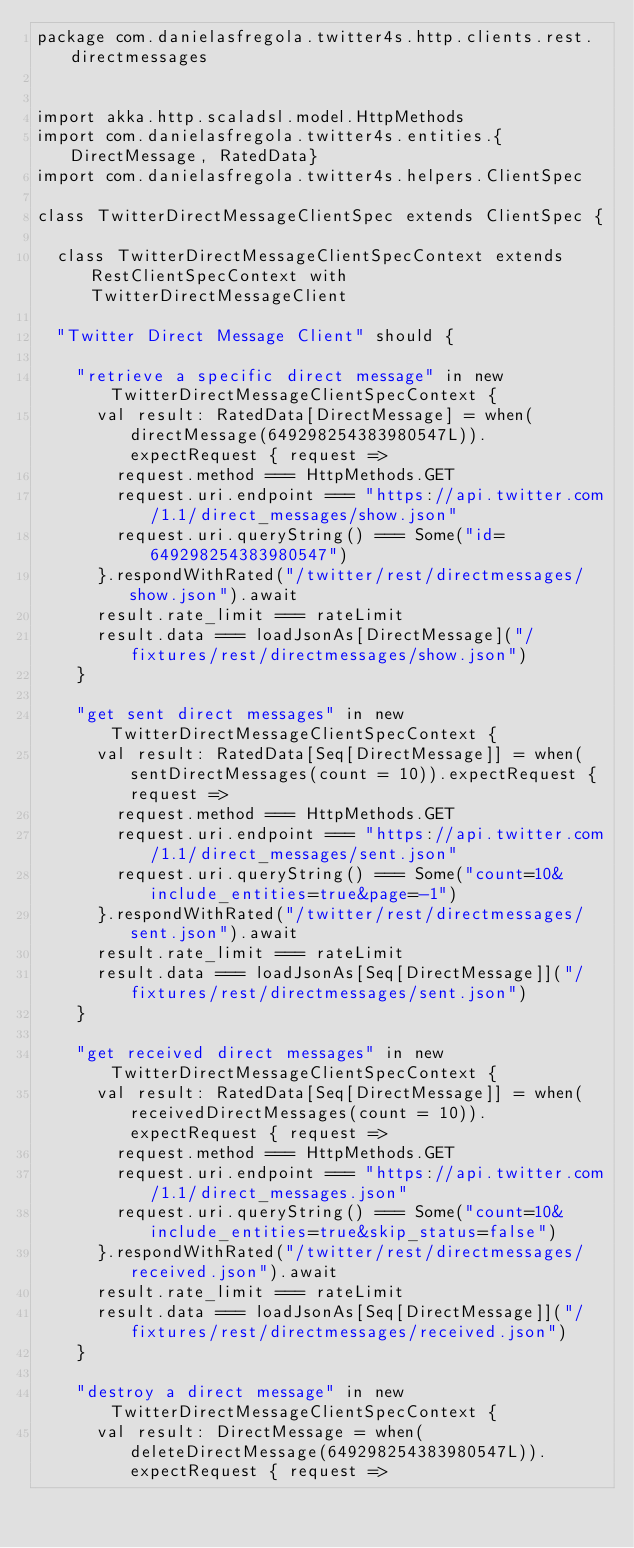<code> <loc_0><loc_0><loc_500><loc_500><_Scala_>package com.danielasfregola.twitter4s.http.clients.rest.directmessages


import akka.http.scaladsl.model.HttpMethods
import com.danielasfregola.twitter4s.entities.{DirectMessage, RatedData}
import com.danielasfregola.twitter4s.helpers.ClientSpec

class TwitterDirectMessageClientSpec extends ClientSpec {

  class TwitterDirectMessageClientSpecContext extends RestClientSpecContext with TwitterDirectMessageClient

  "Twitter Direct Message Client" should {

    "retrieve a specific direct message" in new TwitterDirectMessageClientSpecContext {
      val result: RatedData[DirectMessage] = when(directMessage(649298254383980547L)).expectRequest { request =>
        request.method === HttpMethods.GET
        request.uri.endpoint === "https://api.twitter.com/1.1/direct_messages/show.json"
        request.uri.queryString() === Some("id=649298254383980547")
      }.respondWithRated("/twitter/rest/directmessages/show.json").await
      result.rate_limit === rateLimit
      result.data === loadJsonAs[DirectMessage]("/fixtures/rest/directmessages/show.json")
    }

    "get sent direct messages" in new TwitterDirectMessageClientSpecContext {
      val result: RatedData[Seq[DirectMessage]] = when(sentDirectMessages(count = 10)).expectRequest { request =>
        request.method === HttpMethods.GET
        request.uri.endpoint === "https://api.twitter.com/1.1/direct_messages/sent.json"
        request.uri.queryString() === Some("count=10&include_entities=true&page=-1")
      }.respondWithRated("/twitter/rest/directmessages/sent.json").await
      result.rate_limit === rateLimit
      result.data === loadJsonAs[Seq[DirectMessage]]("/fixtures/rest/directmessages/sent.json")
    }

    "get received direct messages" in new TwitterDirectMessageClientSpecContext {
      val result: RatedData[Seq[DirectMessage]] = when(receivedDirectMessages(count = 10)).expectRequest { request =>
        request.method === HttpMethods.GET
        request.uri.endpoint === "https://api.twitter.com/1.1/direct_messages.json"
        request.uri.queryString() === Some("count=10&include_entities=true&skip_status=false")
      }.respondWithRated("/twitter/rest/directmessages/received.json").await
      result.rate_limit === rateLimit
      result.data === loadJsonAs[Seq[DirectMessage]]("/fixtures/rest/directmessages/received.json")
    }

    "destroy a direct message" in new TwitterDirectMessageClientSpecContext {
      val result: DirectMessage = when(deleteDirectMessage(649298254383980547L)).expectRequest { request =></code> 